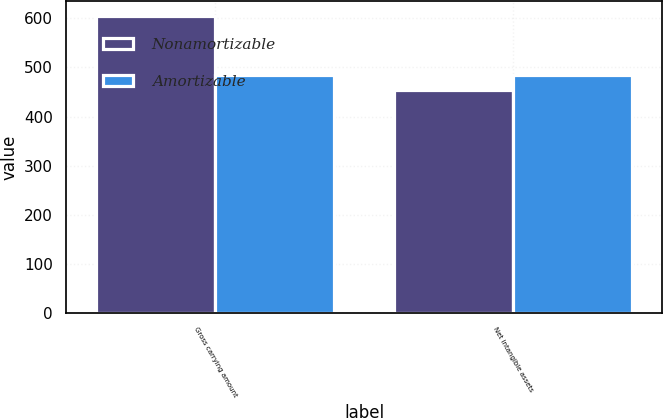Convert chart to OTSL. <chart><loc_0><loc_0><loc_500><loc_500><stacked_bar_chart><ecel><fcel>Gross carrying amount<fcel>Net intangible assets<nl><fcel>Nonamortizable<fcel>604<fcel>454<nl><fcel>Amortizable<fcel>484<fcel>484<nl></chart> 